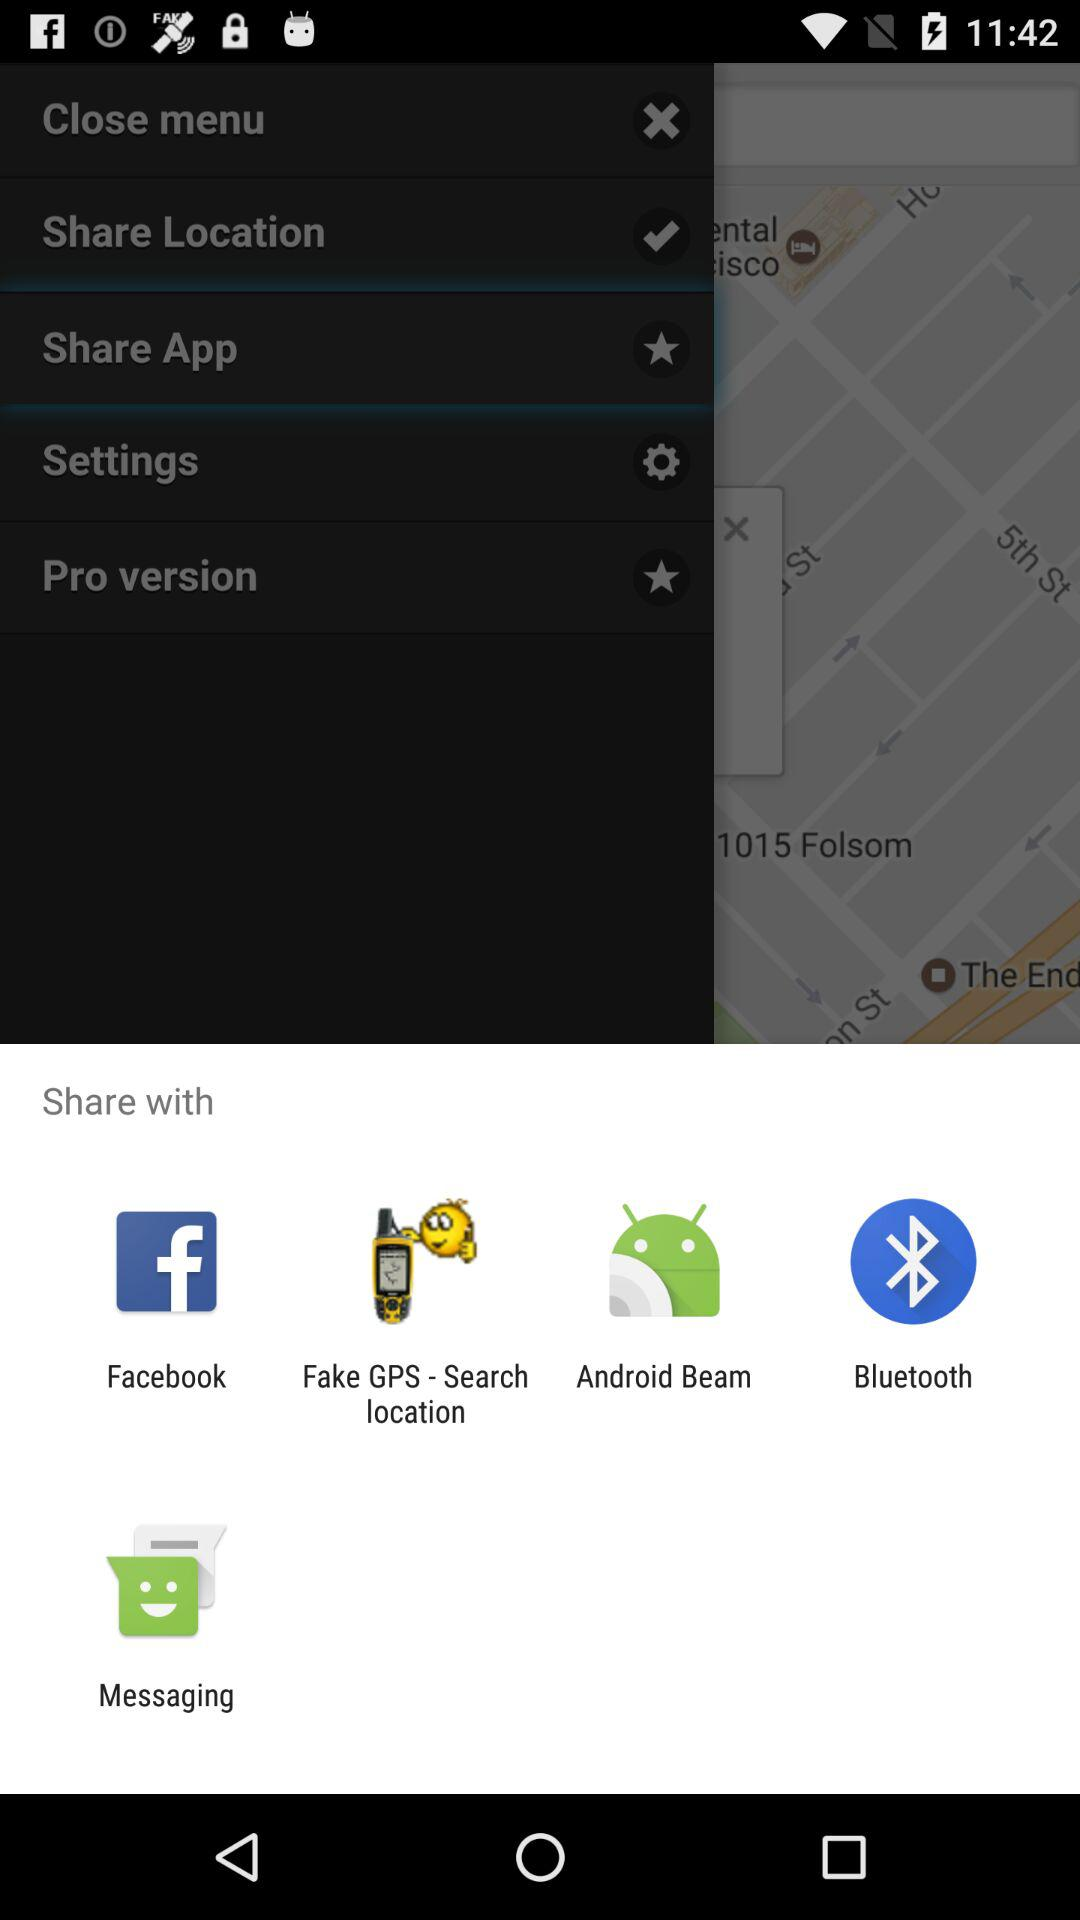Through what applications can we share? The applications through what we can share are "Facebook", "Fake GPS - Search location", "Android Beam", "Bluetooth" and "Messaging". 